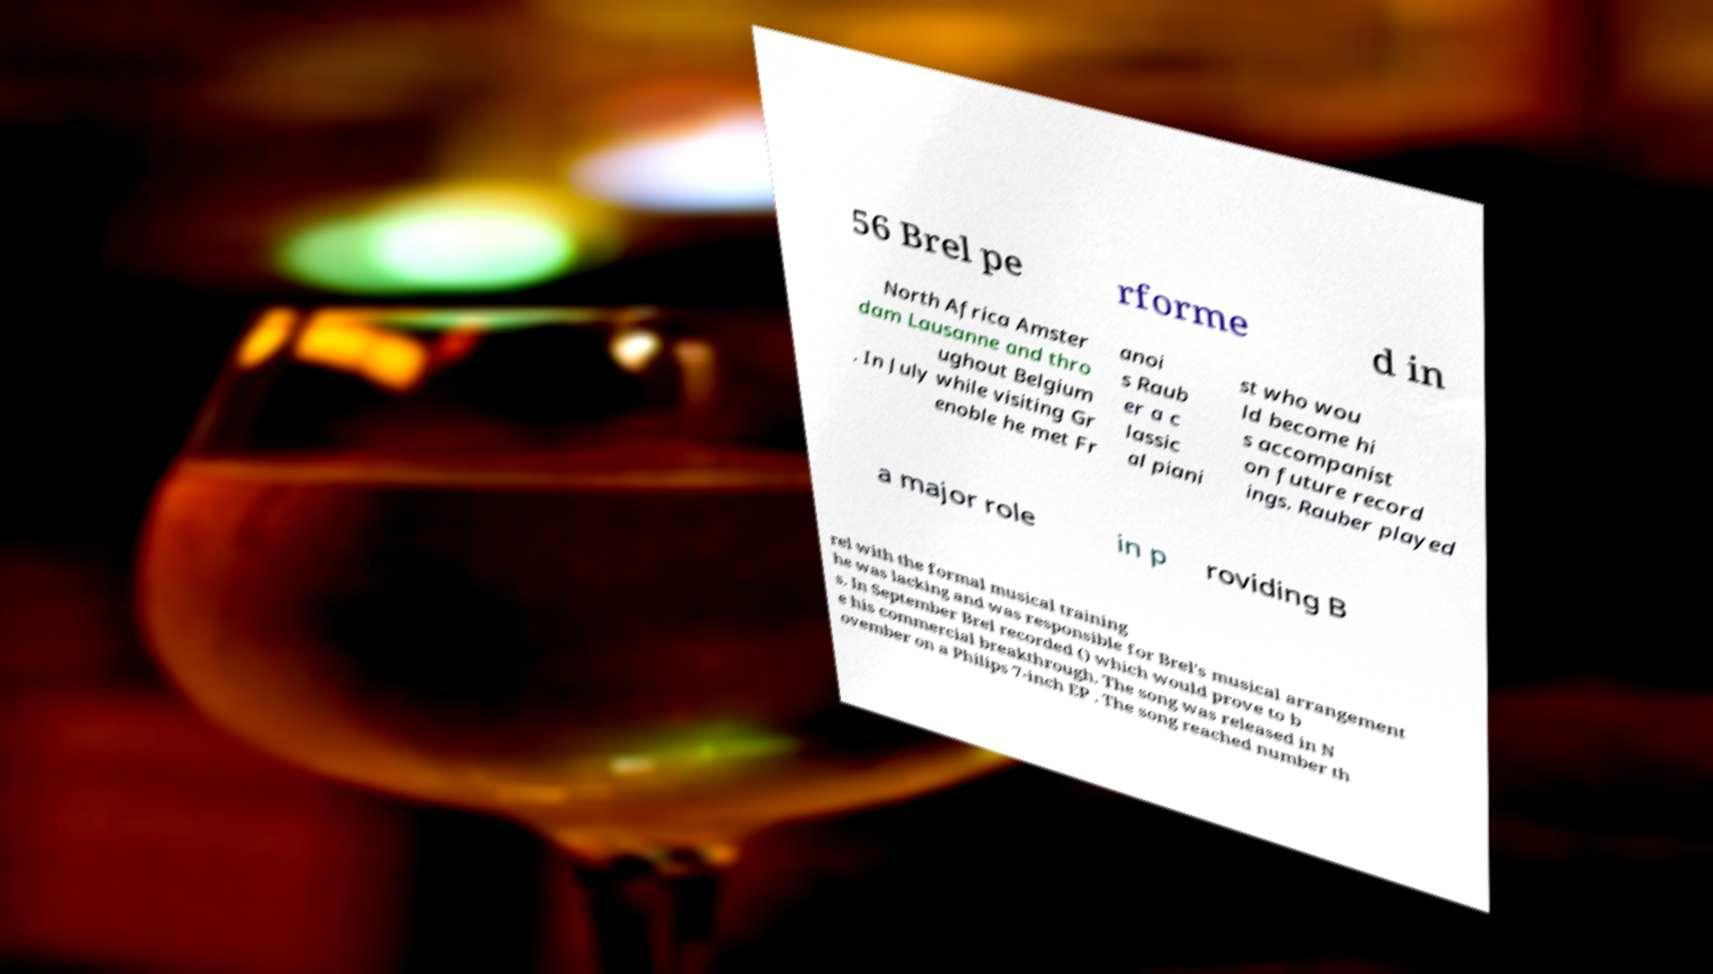Can you read and provide the text displayed in the image?This photo seems to have some interesting text. Can you extract and type it out for me? 56 Brel pe rforme d in North Africa Amster dam Lausanne and thro ughout Belgium . In July while visiting Gr enoble he met Fr anoi s Raub er a c lassic al piani st who wou ld become hi s accompanist on future record ings. Rauber played a major role in p roviding B rel with the formal musical training he was lacking and was responsible for Brel's musical arrangement s. In September Brel recorded () which would prove to b e his commercial breakthrough. The song was released in N ovember on a Philips 7-inch EP . The song reached number th 